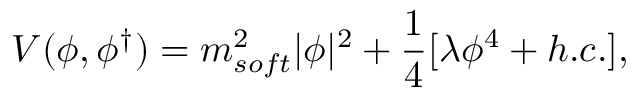Convert formula to latex. <formula><loc_0><loc_0><loc_500><loc_500>V ( \phi , \phi ^ { \dagger } ) = m _ { s o f t } ^ { 2 } | \phi | ^ { 2 } + \frac { 1 } { 4 } [ \lambda \phi ^ { 4 } + h . c . ] ,</formula> 